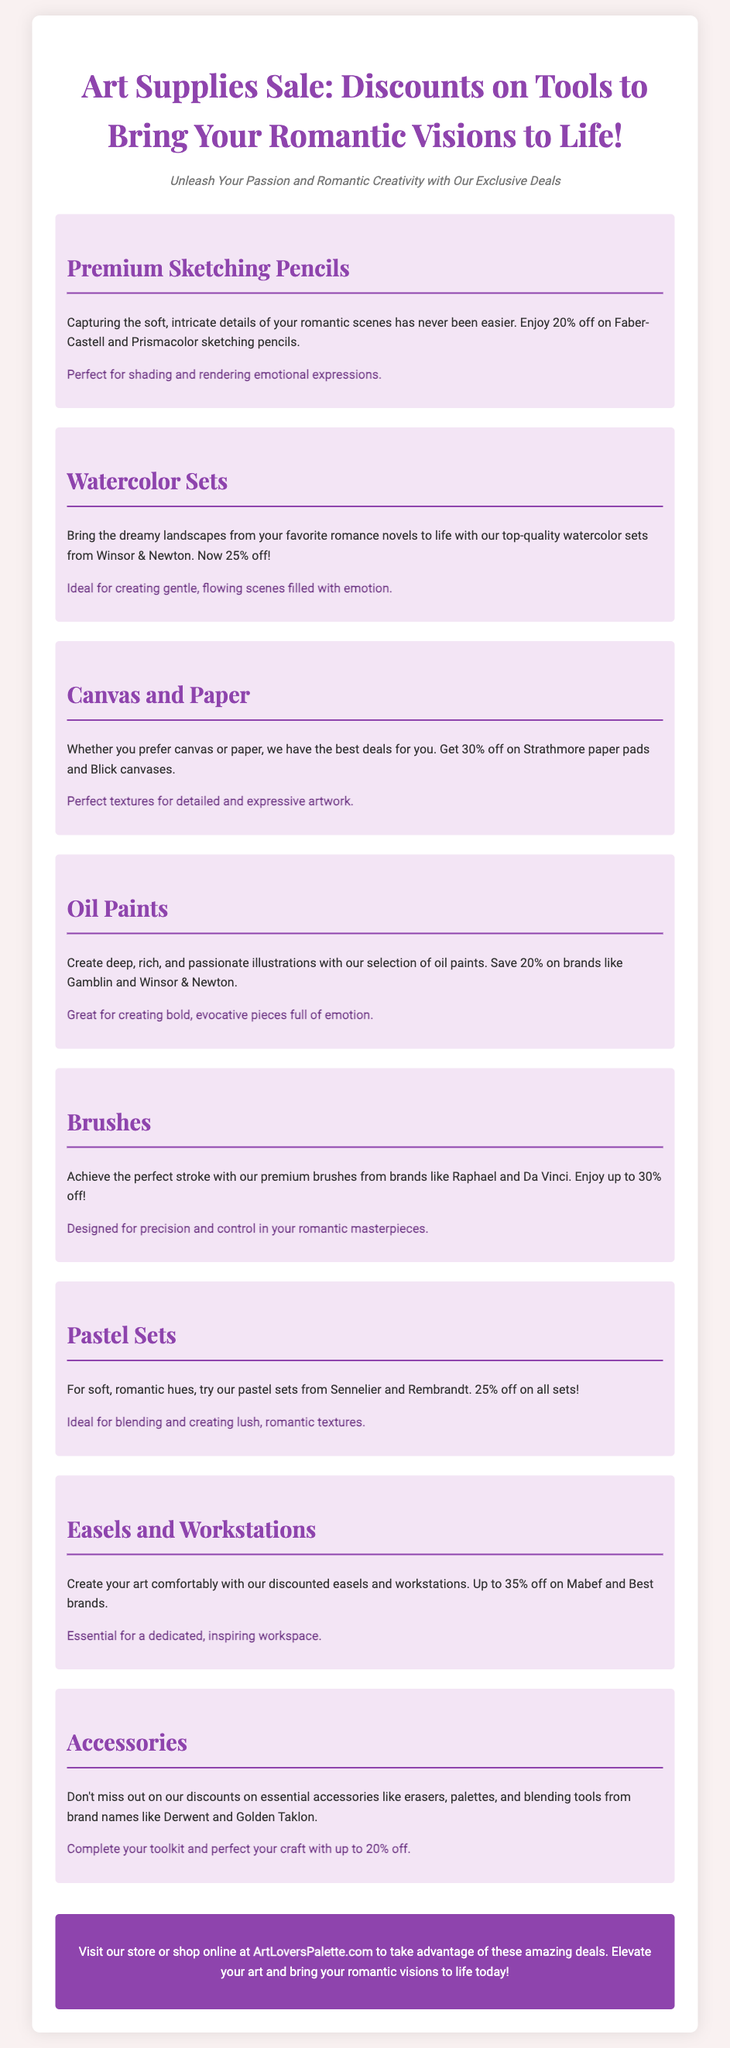What is the sale percentage for watercolor sets? The document states that watercolor sets from Winsor & Newton are now 25% off.
Answer: 25% Which brand offers premium sketching pencils? The flyer mentions Faber-Castell and Prismacolor as the brands for premium sketching pencils.
Answer: Faber-Castell and Prismacolor What is the discount on easels and workstations? The sale offers up to 35% off on easels and workstations.
Answer: 35% What type of art supplies is available for blending? The document highlights pastel sets, which are ideal for blending and creating romantic textures.
Answer: Pastel sets Which brand offers brushes discounted up to 30%? The flyer mentions Raphael and Da Vinci as brands for brushes that are discounted.
Answer: Raphael and Da Vinci What is the focus of the art supplies sale? The document emphasizes bringing romantic visions to life with art supplies.
Answer: Romantic visions What is the maximum discount percentage mentioned for canvas? The flyer states that there is a 30% discount on Blick canvases.
Answer: 30% What type of tools are included under accessories? Essential accessories include erasers, palettes, and blending tools.
Answer: Erasers, palettes, and blending tools What is the main call to action in the flyer? The flyer encourages visiting the store or shopping online at ArtLoversPalette.com.
Answer: Visit our store or shop online at ArtLoversPalette.com 